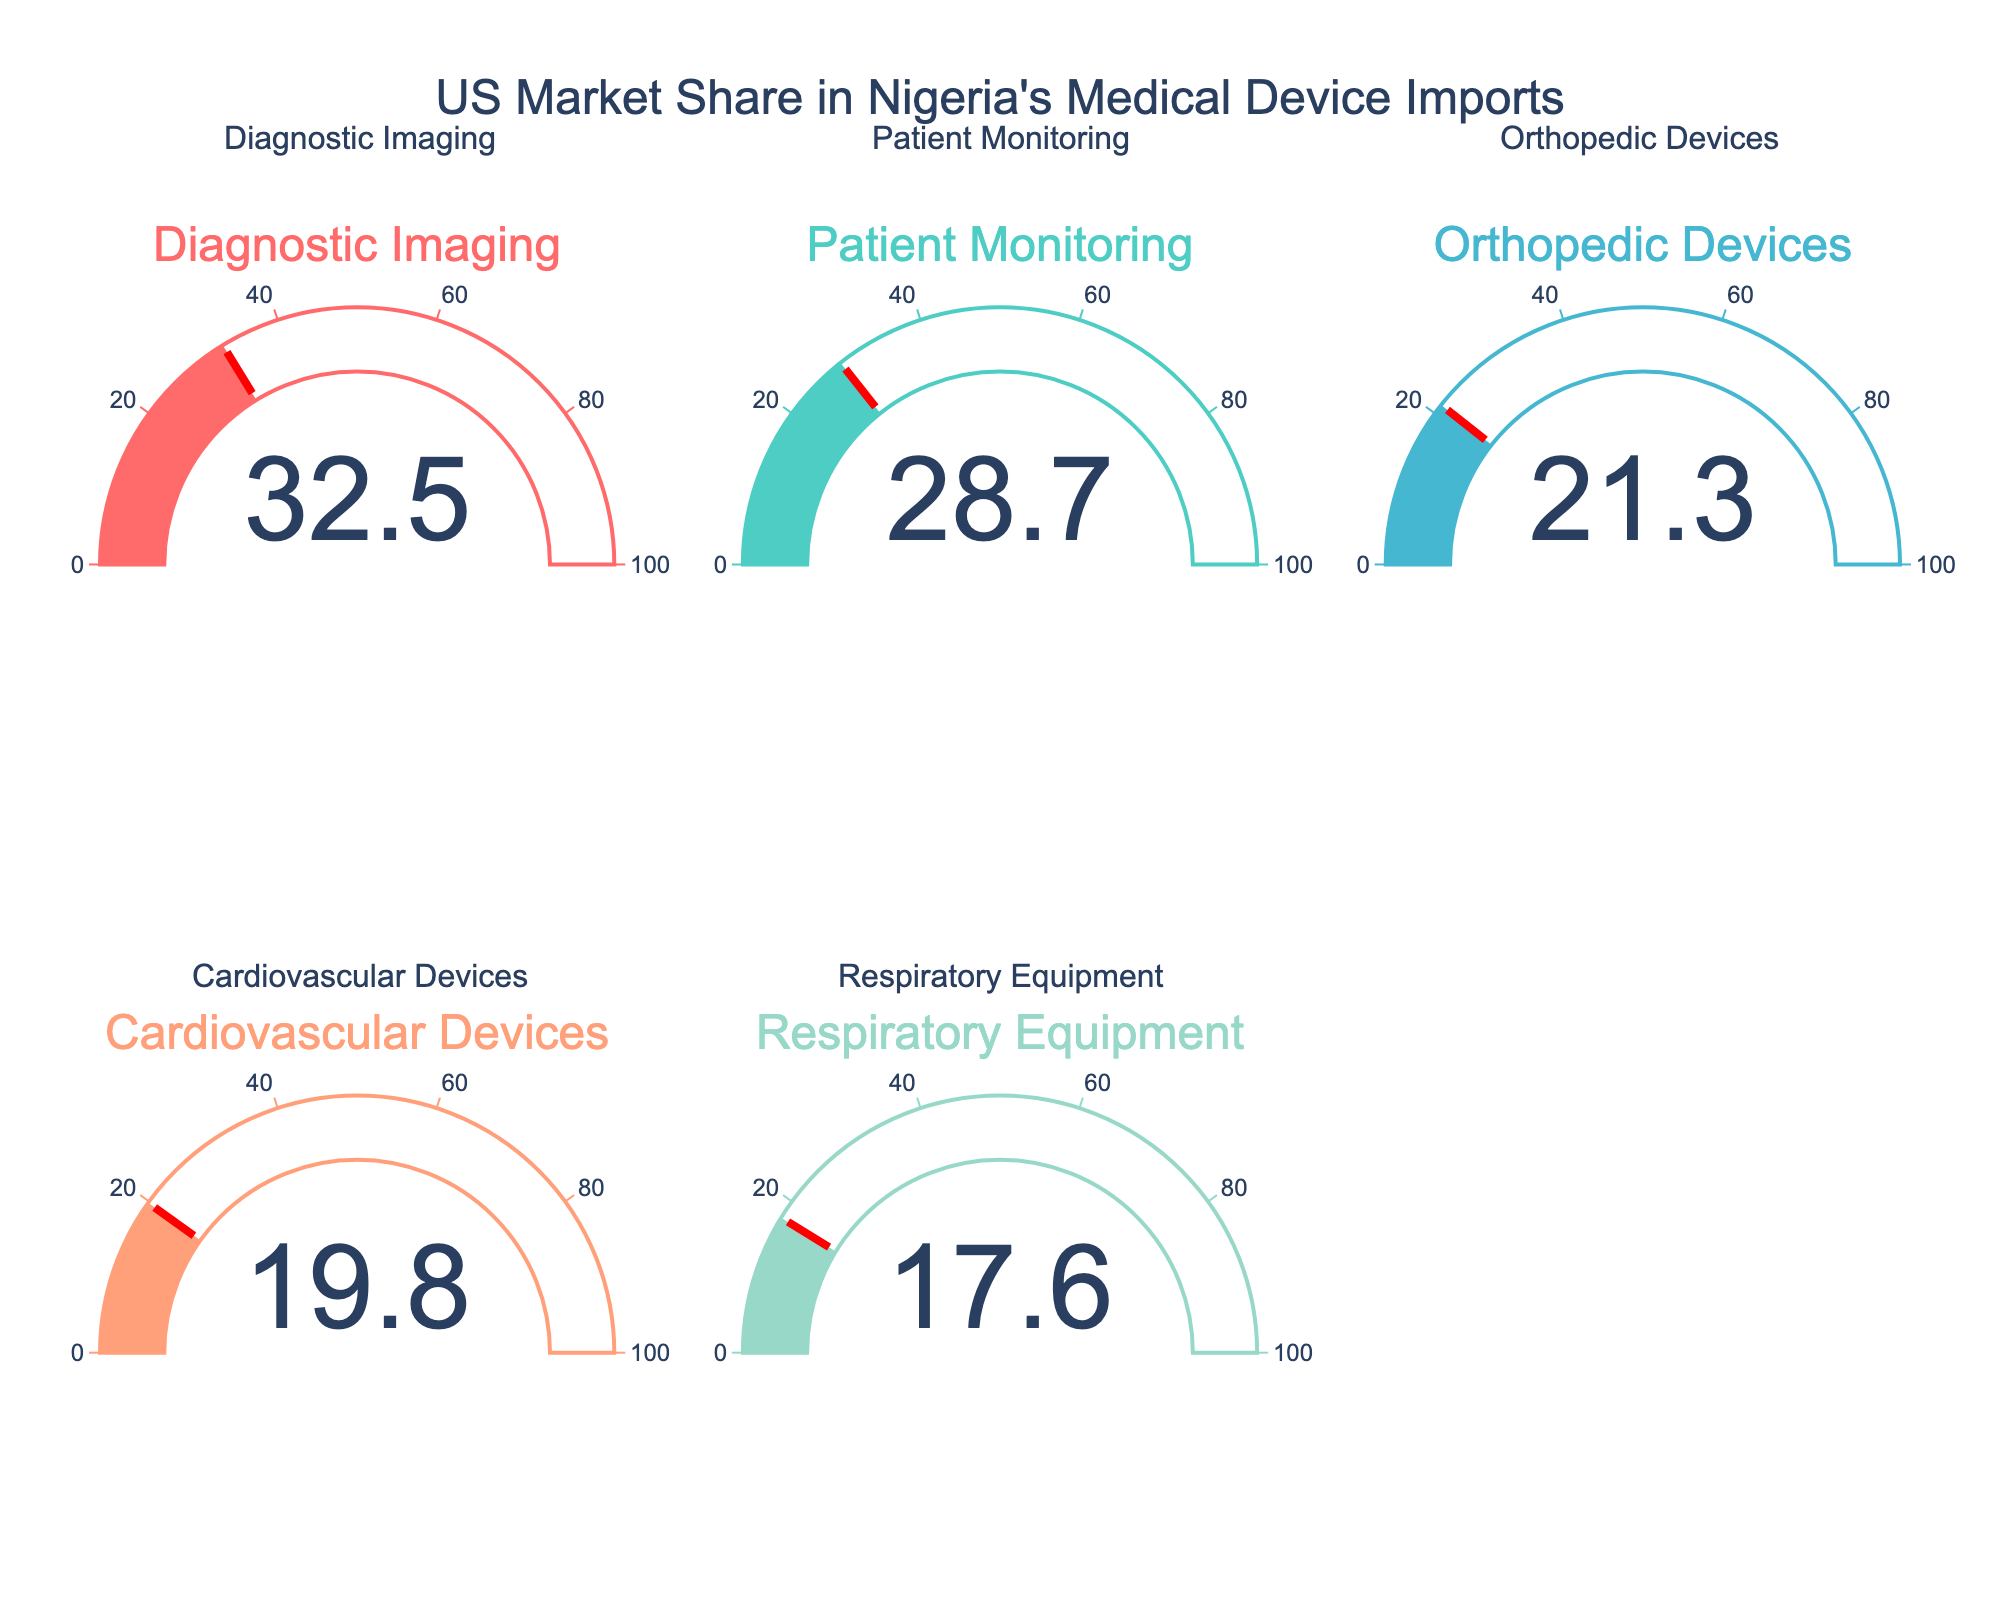what is the US market share in Nigeria's Diagnostic Imaging imports? The Diagnostic Imaging gauge shows a market share value.
Answer: 32.5% which category has the lowest US market share in Nigeria's medical device imports? Compare the gauge values for all categories and identify the smallest.
Answer: Respiratory Equipment what is the combined market share of Patient Monitoring and Cardiovascular Devices? Add the market share values of Patient Monitoring (28.7%) and Cardiovascular Devices (19.8%).
Answer: 48.5% how does the US market share for Orthopedic Devices compare to Cardiovascular Devices? Compare the market share values of Orthopedic Devices (21.3%) and Cardiovascular Devices (19.8%).
Answer: Orthopedic Devices is higher which category's market share closely aligns with the average of all categories shown? Calculate the average market share of all categories: (32.5% + 28.7% + 21.3% + 19.8% + 17.6%) / 5 = 24.98%. Then, identify the category closest to this average.
Answer: Orthopedic Devices by how much does the market share of Diagnostic Imaging exceed Respiratory Equipment? Subtract the market share of Respiratory Equipment (17.6%) from Diagnostic Imaging (32.5%).
Answer: 14.9% which two categories' market shares add up to roughly half of the total market share represented? Identify pairs whose combined total is close to 50%. (Diagnostic Imaging 32.5% + Respiratory Equipment 17.6%) = 50.1%.
Answer: Diagnostic Imaging and Respiratory Equipment is the US market share for Patient Monitoring higher than Orthopedic Devices? Compare the market share values of Patient Monitoring (28.7%) and Orthopedic Devices (21.3%).
Answer: Yes how does the US market share for Patient Monitoring compare to Diagnostic Imaging? Compare the market share values of Patient Monitoring (28.7%) and Diagnostic Imaging (32.5%).
Answer: Diagnostic Imaging is higher if the US were to increase its market share in Cardiovascular Devices by 10%, what would be the new market share? Add 10% to the current market share of Cardiovascular Devices (19.8% + 10%).
Answer: 29.8% 